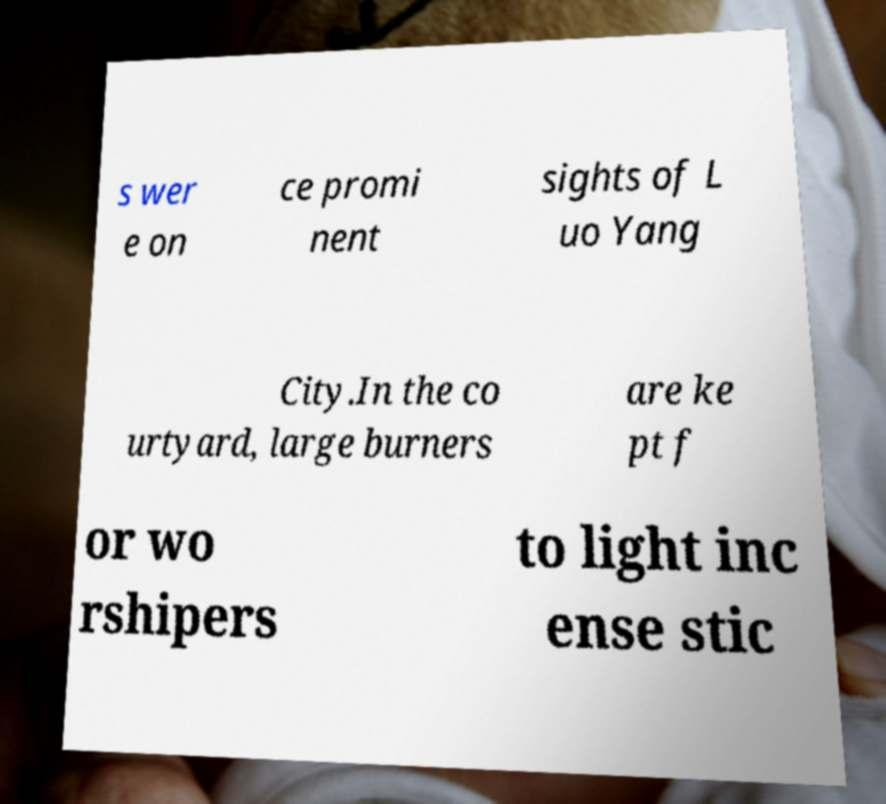For documentation purposes, I need the text within this image transcribed. Could you provide that? s wer e on ce promi nent sights of L uo Yang City.In the co urtyard, large burners are ke pt f or wo rshipers to light inc ense stic 